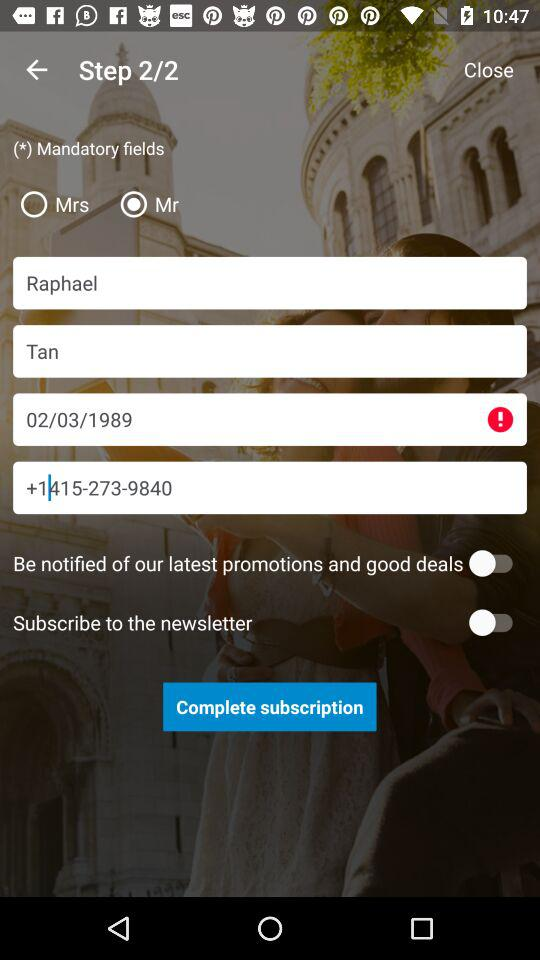What is the full name? The full name is Raphael Tan. 